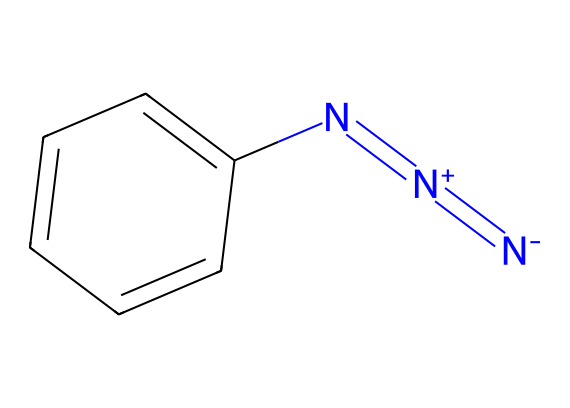What is the molecular formula of phenyl azide? To determine the molecular formula, count the number of each type of atom in the SMILES representation: there are 6 carbon (C) atoms from the phenyl ring, 1 nitrogen (N) atom from the azide group, and an additional 2 nitrogen (N) atoms, giving a total of 3 nitrogen atoms. Thus, the molecular formula is C6H5N3.
Answer: C6H5N3 How many nitrogen atoms are present in phenyl azide? From the SMILES representation, we can see there are three nitrogen atoms represented in the azide group (indicated by "N=[N+]=[N-]").
Answer: 3 What is the main functional group in phenyl azide? The azide functional group is characterized by the presence of three nitrogen atoms connected linearly (N=N=N) and is indicated in the structure.
Answer: azide How does the structure of phenyl azide support its use in photosensitive materials? The presence of the azide functional group allows phenyl azide to undergo photolysis upon exposure to UV light, leading to the formation of reactive intermediates that can be used for cross-linking in photosensitive applications.
Answer: photolysis What type of reactivity does the azide functional group exhibit? The azide functional group is known for its thermal and photo-reactivity, allowing it to participate in various reactions such as cycloadditions and decompositions upon heating or UV irradiation.
Answer: thermal and photo-reactivity Which part of the molecule contributes to its photosensitivity? The azide group (N=N=N) is responsible for the photosensitivity due to its ability to undergo reactions upon exposure to light, specifically UV light, making it useful in developing innovative display materials.
Answer: azide group 